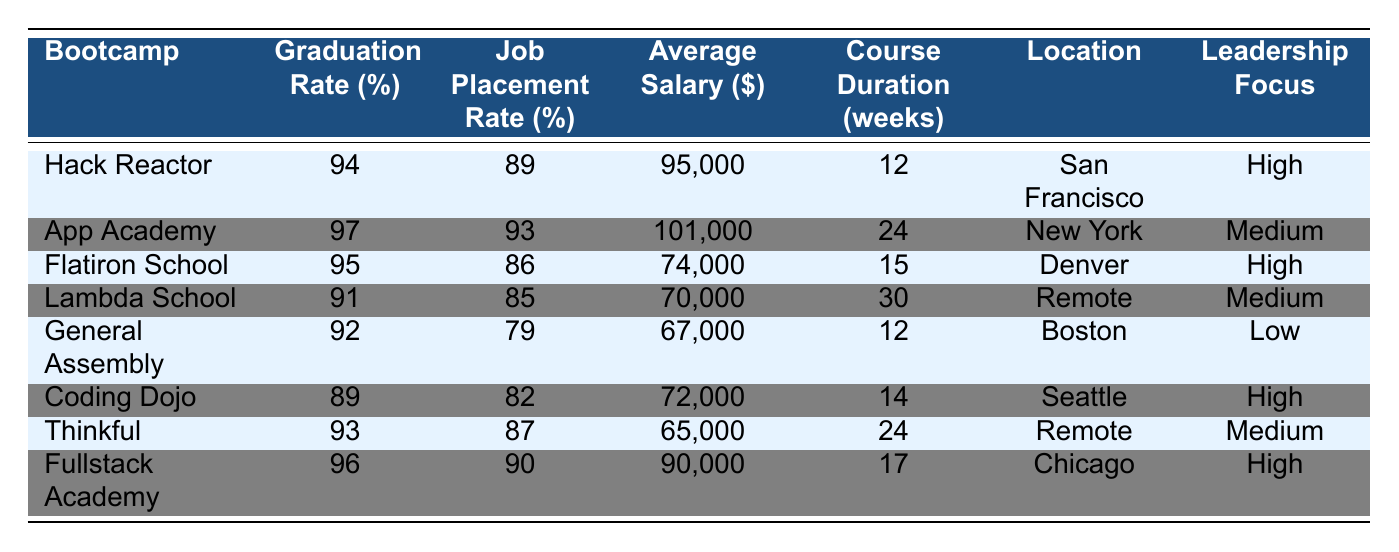What is the graduation rate for App Academy? From the table, under the column for Graduation Rate, the value for App Academy is listed as 97%.
Answer: 97% Which bootcamp has the highest average salary? By comparing the Average Salary column, App Academy has the highest salary of $101,000.
Answer: App Academy What is the job placement rate for General Assembly? Looking at the Job Placement Rate column, General Assembly has a placement rate of 79%.
Answer: 79% How many weeks does the Lambda School course last? Referring to the Course Duration column, Lambda School has a duration of 30 weeks.
Answer: 30 weeks Which bootcamp has a leadership focus labeled as "Low"? In the Leadership Focus column, General Assembly is the only one marked as "Low".
Answer: General Assembly What is the difference in graduation rates between Hack Reactor and Fullstack Academy? Hack Reactor has a graduation rate of 94%, and Fullstack Academy is at 96%. The difference is 96 - 94 = 2%.
Answer: 2% Calculate the average job placement rate of the bootcamps. The job placement rates are: 89, 93, 86, 85, 79, 82, 87, 90. Adding these gives 89 + 93 + 86 + 85 + 79 + 82 + 87 + 90 =  90.5. Dividing by 8 (the number of bootcamps) results in 90.5 / 8 = 84.375%.
Answer: 84.375% Which bootcamp offers the shortest course duration? By checking the Course Duration column, Hack Reactor has the shortest course at 12 weeks.
Answer: Hack Reactor Is the average salary for Coding Dojo higher than for Flatiron School? Coding Dojo has an average salary of $72,000 and Flatiron School has $74,000. Since $72,000 is less than $74,000, the answer is No.
Answer: No What is the overall trend in job placement rates for bootcamps with high leadership focus compared to others? The job placement rates with high leadership focus are: Hack Reactor (89%), Flatiron School (86%), Coding Dojo (82%), Fullstack Academy (90%). The average for high focus: (89 + 86 + 82 + 90) / 4 = 86.75%. The rest (with medium and low focus) average: (93 + 85 + 79 + 87) / 4 = 86. The trend suggests that those with high leadership focus have slightly better placements.
Answer: High leadership focus has better job placement rates 